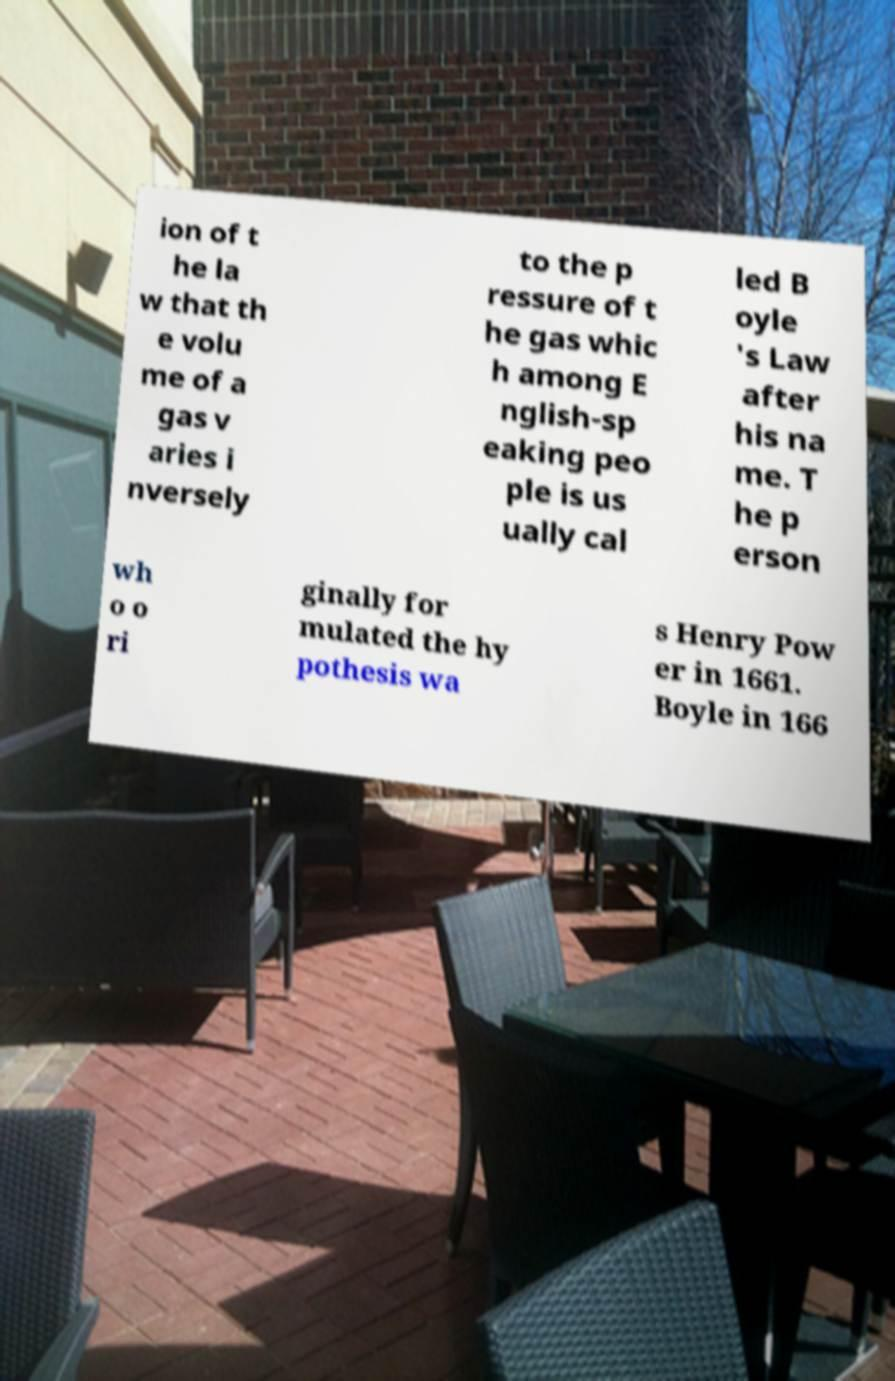Could you assist in decoding the text presented in this image and type it out clearly? ion of t he la w that th e volu me of a gas v aries i nversely to the p ressure of t he gas whic h among E nglish-sp eaking peo ple is us ually cal led B oyle 's Law after his na me. T he p erson wh o o ri ginally for mulated the hy pothesis wa s Henry Pow er in 1661. Boyle in 166 